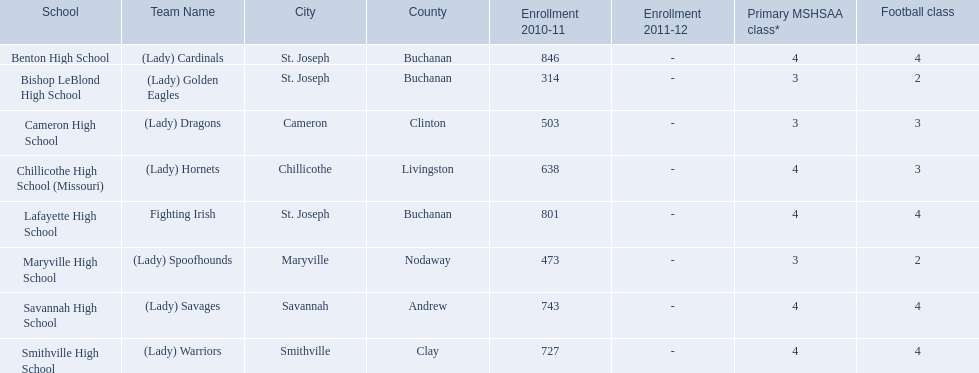What team uses green and grey as colors? Fighting Irish. What is this team called? Lafayette High School. 